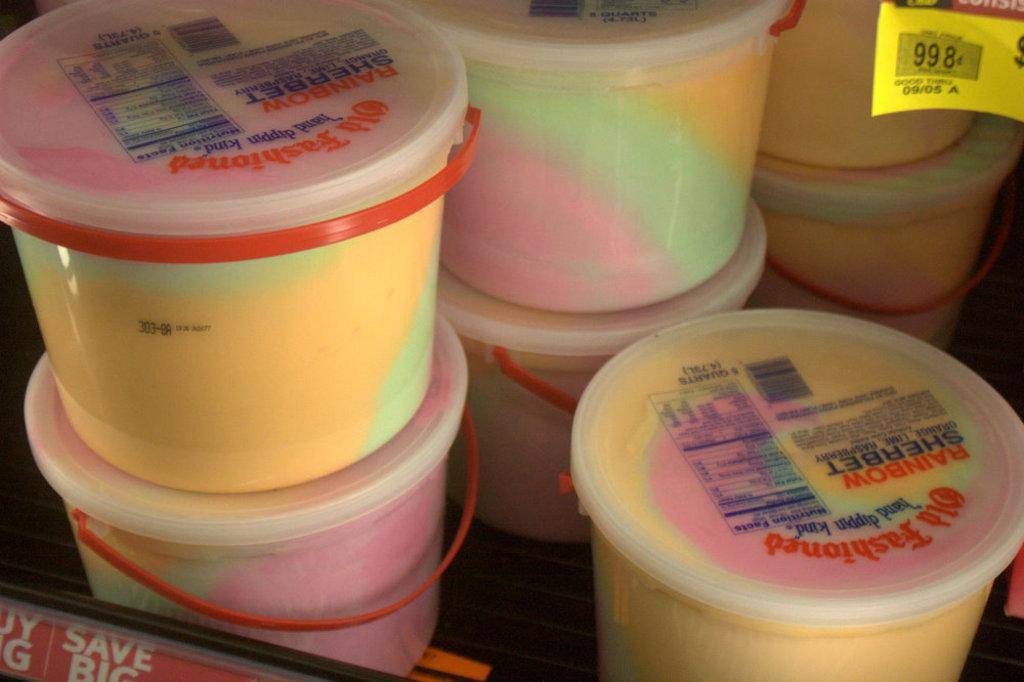<image>
Write a terse but informative summary of the picture. Many tubs of rainbow sherbert ice cream are in a refrigerator. 